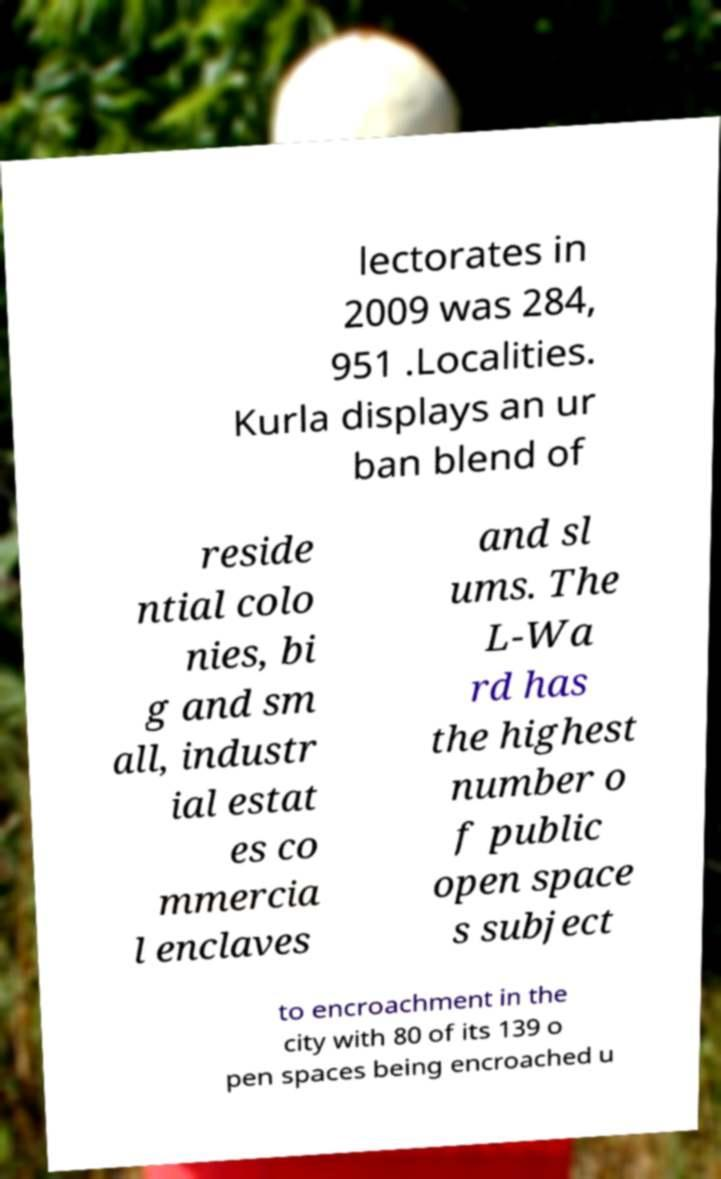Can you read and provide the text displayed in the image?This photo seems to have some interesting text. Can you extract and type it out for me? lectorates in 2009 was 284, 951 .Localities. Kurla displays an ur ban blend of reside ntial colo nies, bi g and sm all, industr ial estat es co mmercia l enclaves and sl ums. The L-Wa rd has the highest number o f public open space s subject to encroachment in the city with 80 of its 139 o pen spaces being encroached u 